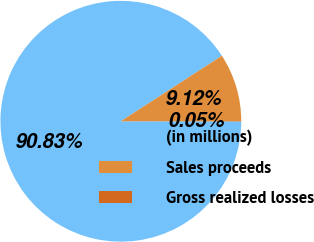Convert chart. <chart><loc_0><loc_0><loc_500><loc_500><pie_chart><fcel>(in millions)<fcel>Sales proceeds<fcel>Gross realized losses<nl><fcel>90.83%<fcel>9.12%<fcel>0.05%<nl></chart> 